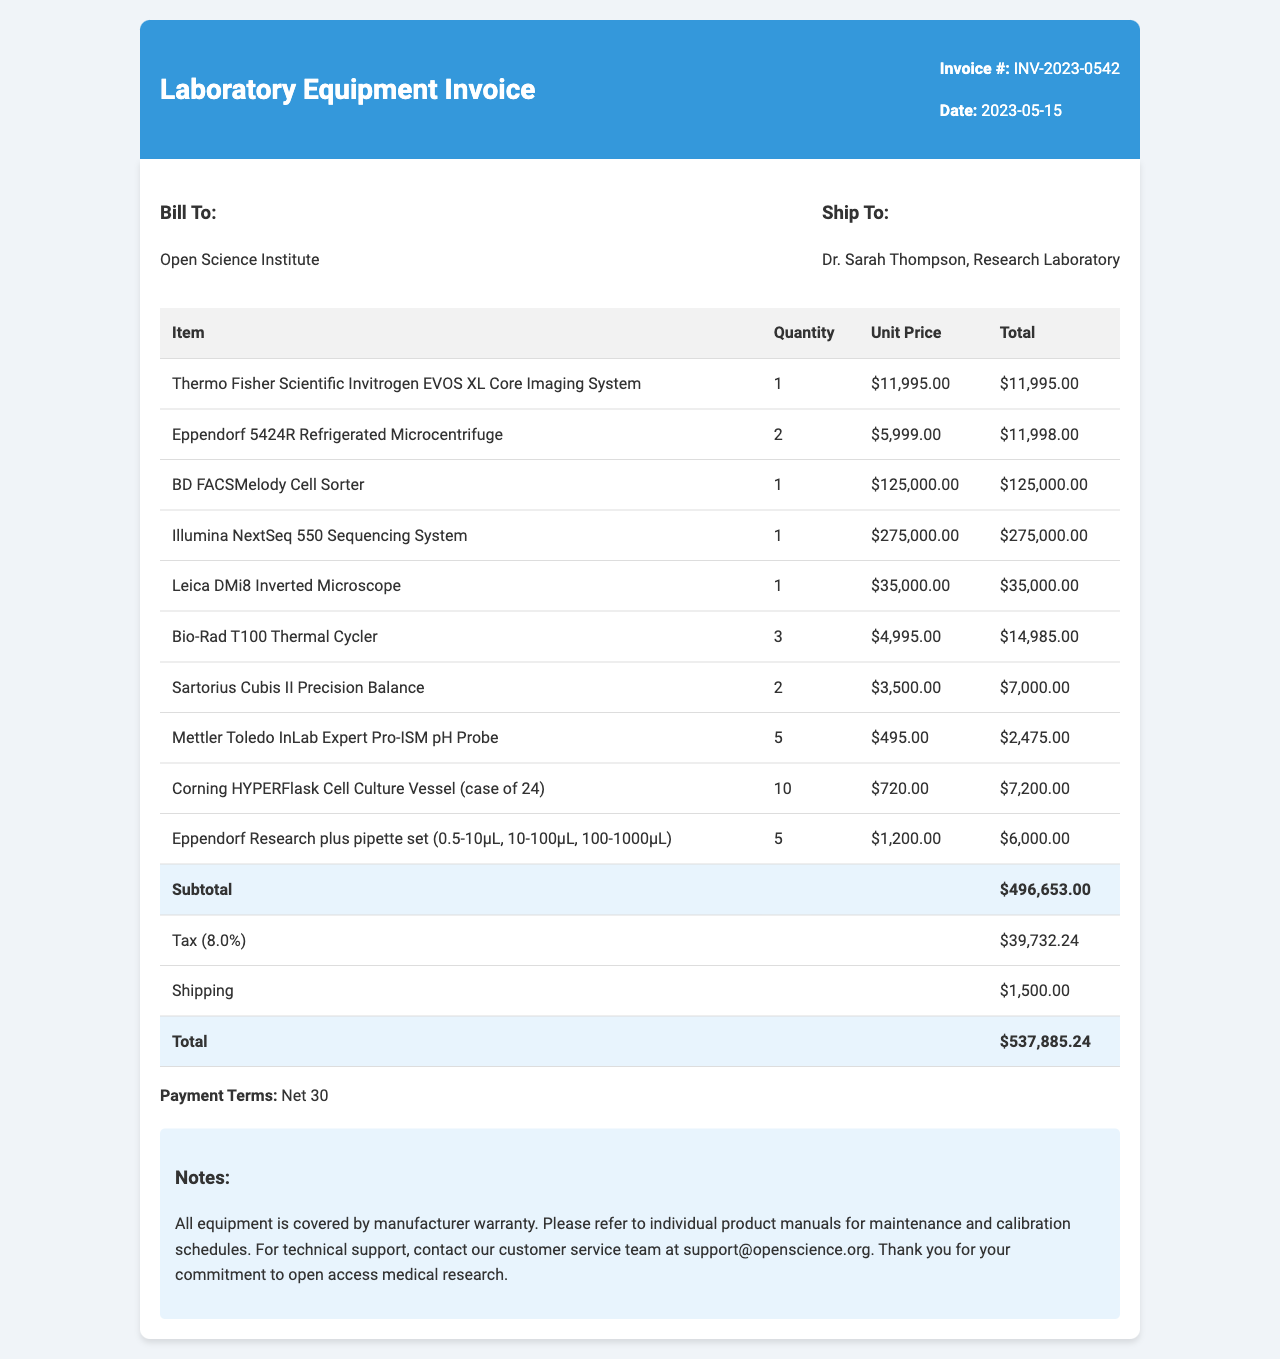What is the invoice number? The invoice number is a unique identifier for this document, which is indicated at the top.
Answer: INV-2023-0542 What is the date of the invoice? The date on the invoice is the day it was issued, which is printed prominently.
Answer: 2023-05-15 Who is the billing entity? The billing entity is the organization responsible for payment, located in the billing section.
Answer: Open Science Institute How many Eppendorf 5424R Refrigerated Microcentrifuges were purchased? The quantity of each item is listed in the invoice, helping to determine the total number of units.
Answer: 2 What is the subtotal amount before tax? The subtotal is the total cost before tax and additional charges, indicated in the invoice summary.
Answer: 496653.00 What is the tax rate applied to the invoice? The tax rate is a percentage that is applied to the subtotal, reflected near the tax amount.
Answer: 8% What is the total amount due for this invoice? The total amount is the final amount payable, combining subtotal, tax, and shipping, listed at the bottom.
Answer: 537885.24 What are the payment terms specified in the invoice? The payment terms outline the conditions under which the payment should be made, provided in the notes section.
Answer: Net 30 What warranty coverage is mentioned for the equipment? The note regarding warranty coverage indicates if there is any assurance on the equipment's performance.
Answer: manufacturer warranty 